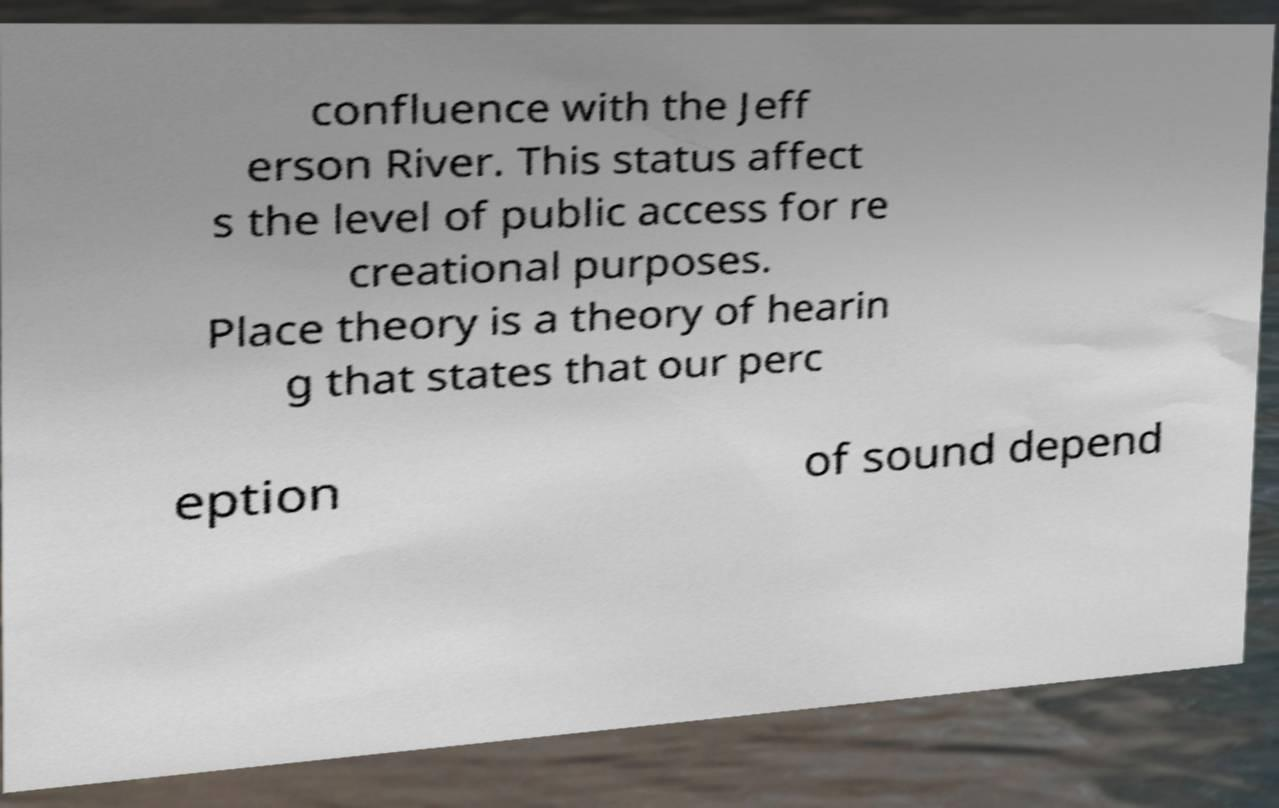For documentation purposes, I need the text within this image transcribed. Could you provide that? confluence with the Jeff erson River. This status affect s the level of public access for re creational purposes. Place theory is a theory of hearin g that states that our perc eption of sound depend 